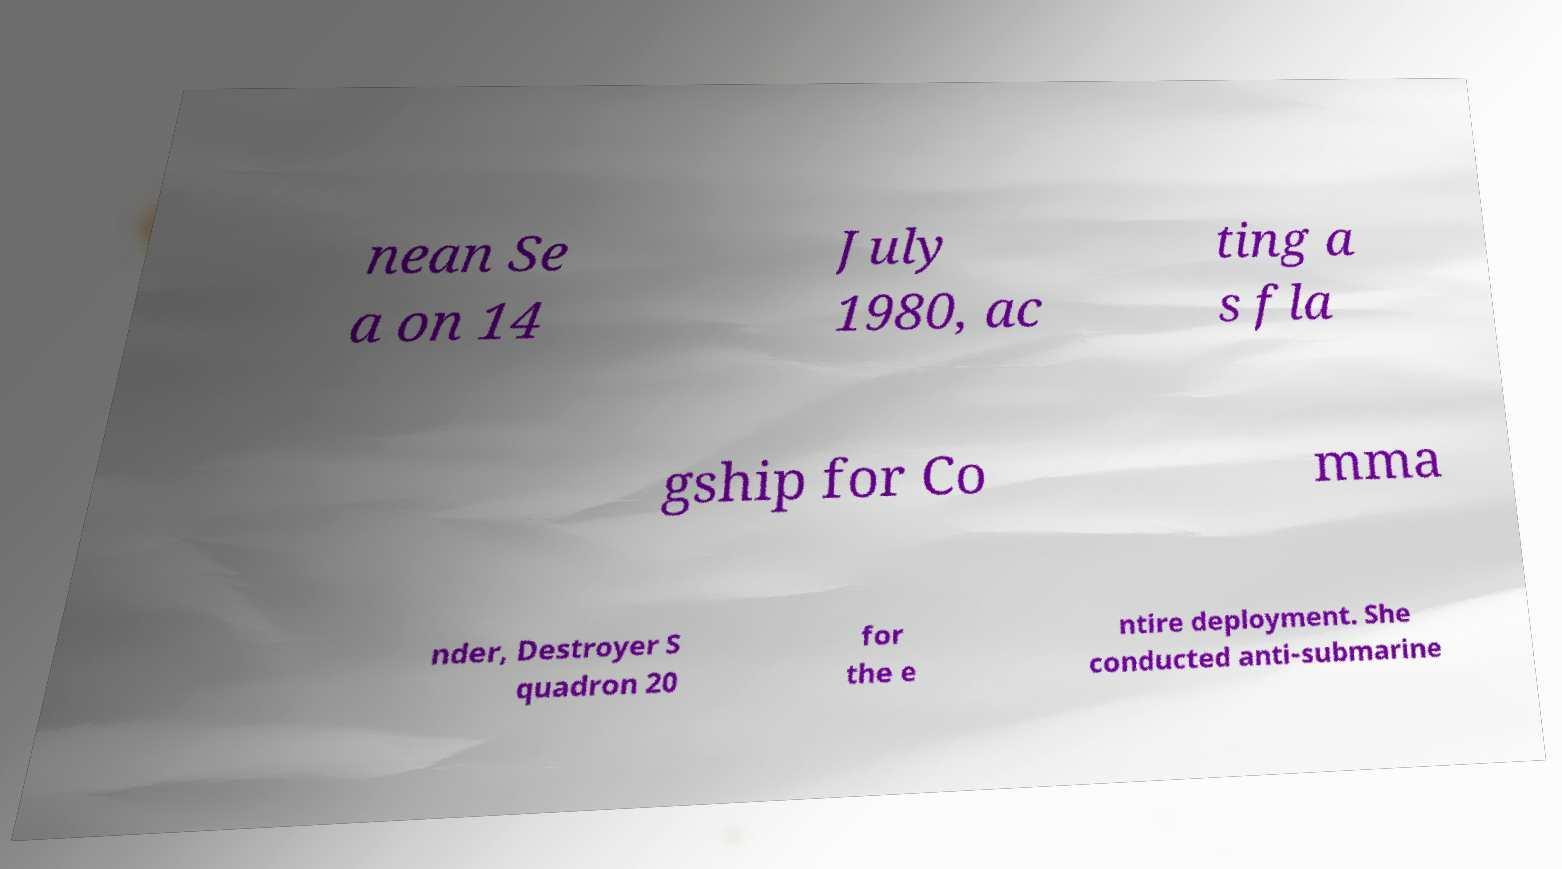What messages or text are displayed in this image? I need them in a readable, typed format. nean Se a on 14 July 1980, ac ting a s fla gship for Co mma nder, Destroyer S quadron 20 for the e ntire deployment. She conducted anti-submarine 